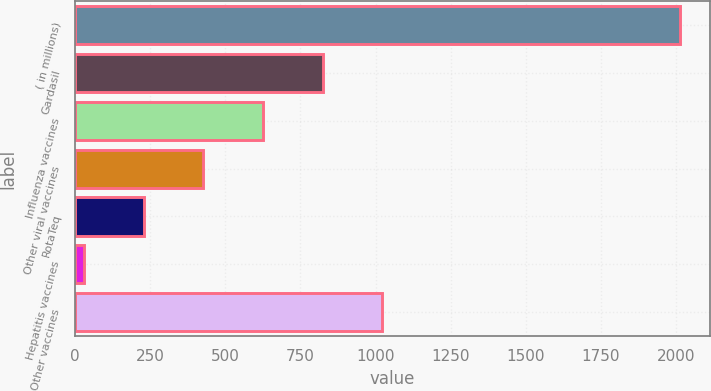Convert chart. <chart><loc_0><loc_0><loc_500><loc_500><bar_chart><fcel>( in millions)<fcel>Gardasil<fcel>Influenza vaccines<fcel>Other viral vaccines<fcel>RotaTeq<fcel>Hepatitis vaccines<fcel>Other vaccines<nl><fcel>2012<fcel>823.4<fcel>625.3<fcel>427.2<fcel>229.1<fcel>31<fcel>1021.5<nl></chart> 